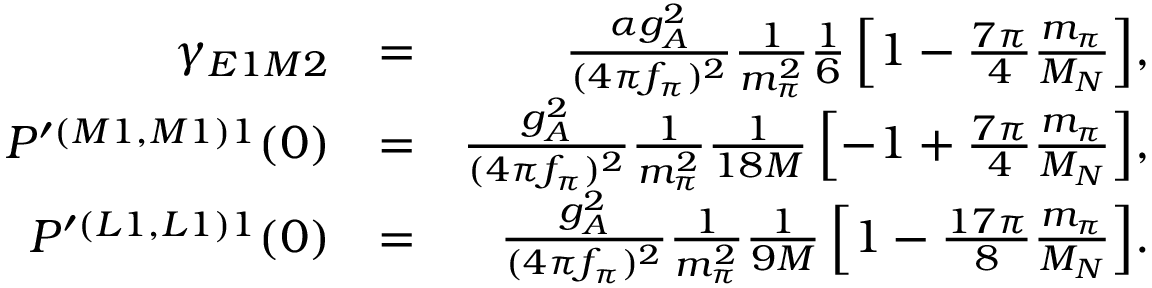<formula> <loc_0><loc_0><loc_500><loc_500>\begin{array} { r l r } { \gamma _ { E 1 M 2 } } & { = } & { \frac { \alpha g _ { A } ^ { 2 } } { ( 4 \pi f _ { \pi } ) ^ { 2 } } \frac { 1 } { m _ { \pi } ^ { 2 } } \frac { 1 } { 6 } \left [ 1 - \frac { 7 \pi } { 4 } \frac { m _ { \pi } } { M _ { N } } \right ] \, , } \\ { P ^ { \prime ( M 1 , M 1 ) 1 } ( 0 ) } & { = } & { \frac { g _ { A } ^ { 2 } } { ( 4 \pi f _ { \pi } ) ^ { 2 } } \frac { 1 } { m _ { \pi } ^ { 2 } } \frac { 1 } { 1 8 M } \left [ - 1 + \frac { 7 \pi } { 4 } \frac { m _ { \pi } } { M _ { N } } \right ] \, , } \\ { P ^ { \prime ( L 1 , L 1 ) 1 } ( 0 ) } & { = } & { \frac { g _ { A } ^ { 2 } } { ( 4 \pi f _ { \pi } ) ^ { 2 } } \frac { 1 } { m _ { \pi } ^ { 2 } } \frac { 1 } { 9 M } \left [ 1 - \frac { 1 7 \pi } { 8 } \frac { m _ { \pi } } { M _ { N } } \right ] \, . } \end{array}</formula> 